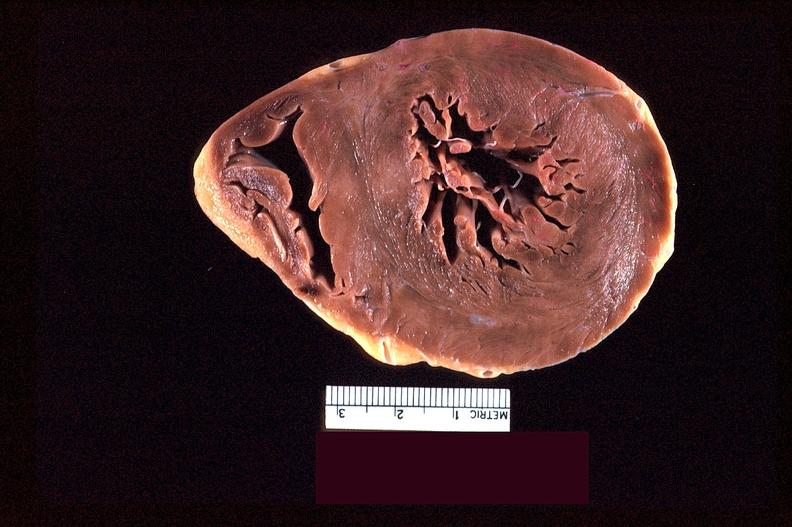does this image show heart slice, acute posterior myocardial infarction in patient with hypertension?
Answer the question using a single word or phrase. Yes 